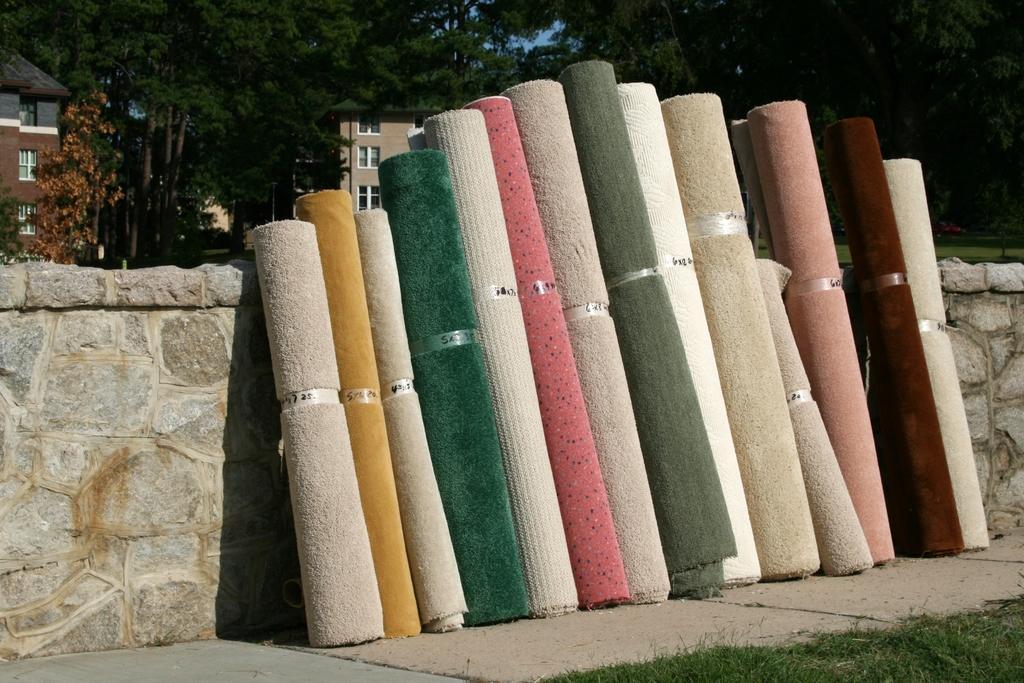Can you describe this image briefly? In this image I see cloth roles which are different in colors and I see the green grass over here and I see the path and the wall. In the background I see the trees, buildings and the blue sky. 